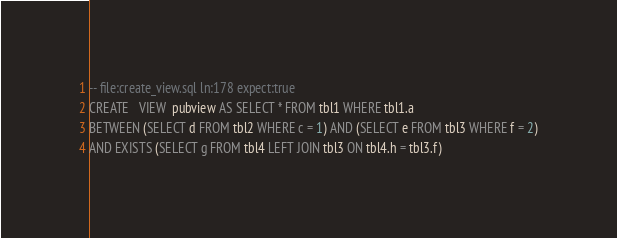Convert code to text. <code><loc_0><loc_0><loc_500><loc_500><_SQL_>-- file:create_view.sql ln:178 expect:true
CREATE   VIEW  pubview AS SELECT * FROM tbl1 WHERE tbl1.a
BETWEEN (SELECT d FROM tbl2 WHERE c = 1) AND (SELECT e FROM tbl3 WHERE f = 2)
AND EXISTS (SELECT g FROM tbl4 LEFT JOIN tbl3 ON tbl4.h = tbl3.f)
</code> 